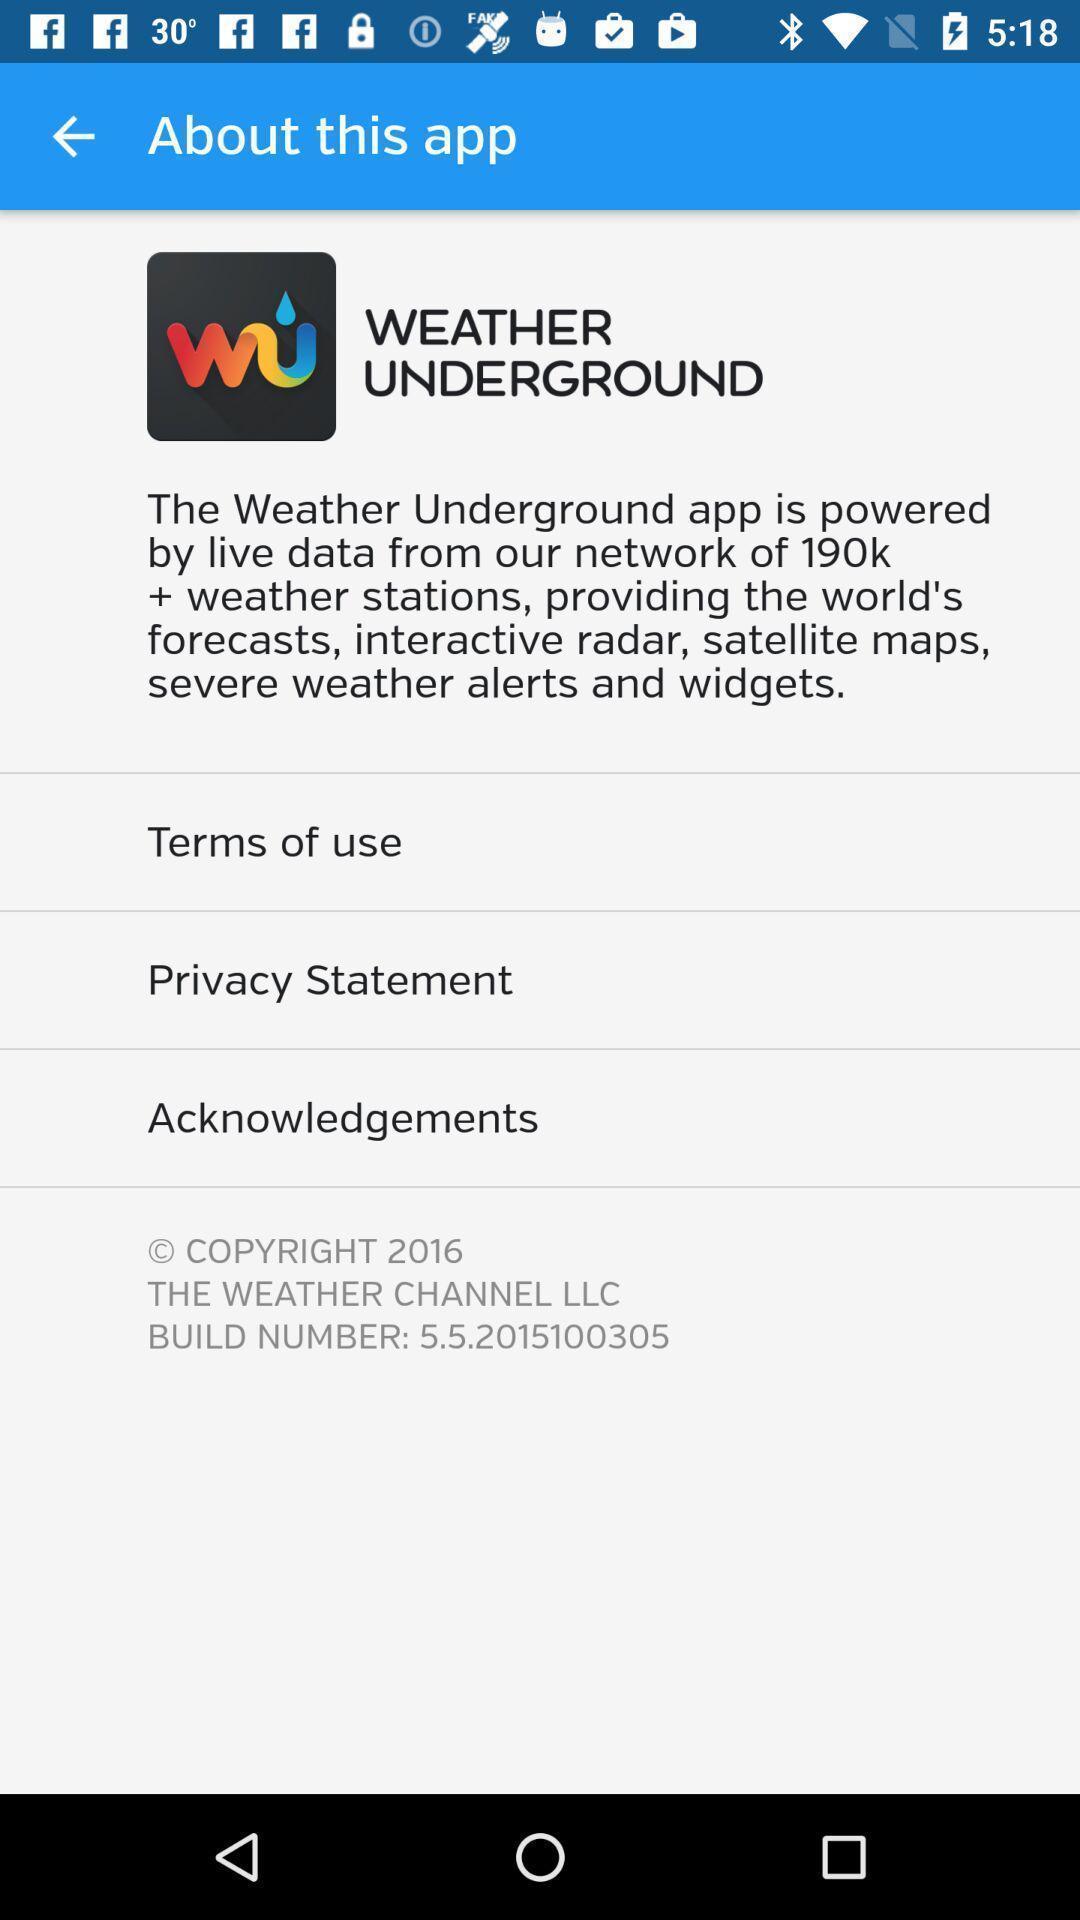Describe this image in words. Page displaying the information of a social app. 